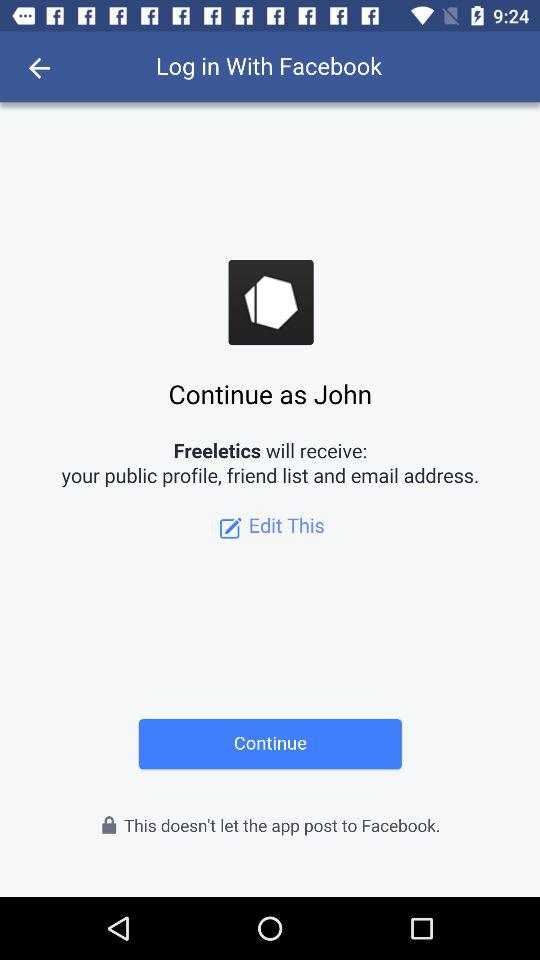Through what application can we log in? You can log in through "Facebook". 